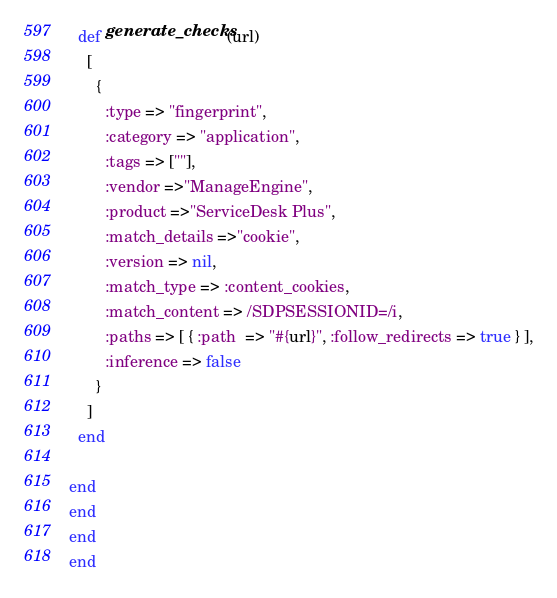<code> <loc_0><loc_0><loc_500><loc_500><_Ruby_>
  def generate_checks(url)
    [
      {
        :type => "fingerprint",
        :category => "application",
        :tags => [""],
        :vendor =>"ManageEngine",
        :product =>"ServiceDesk Plus",
        :match_details =>"cookie",
        :version => nil,
        :match_type => :content_cookies,
        :match_content => /SDPSESSIONID=/i,
        :paths => [ { :path  => "#{url}", :follow_redirects => true } ],
        :inference => false
      }
    ]
  end

end
end
end
end
</code> 